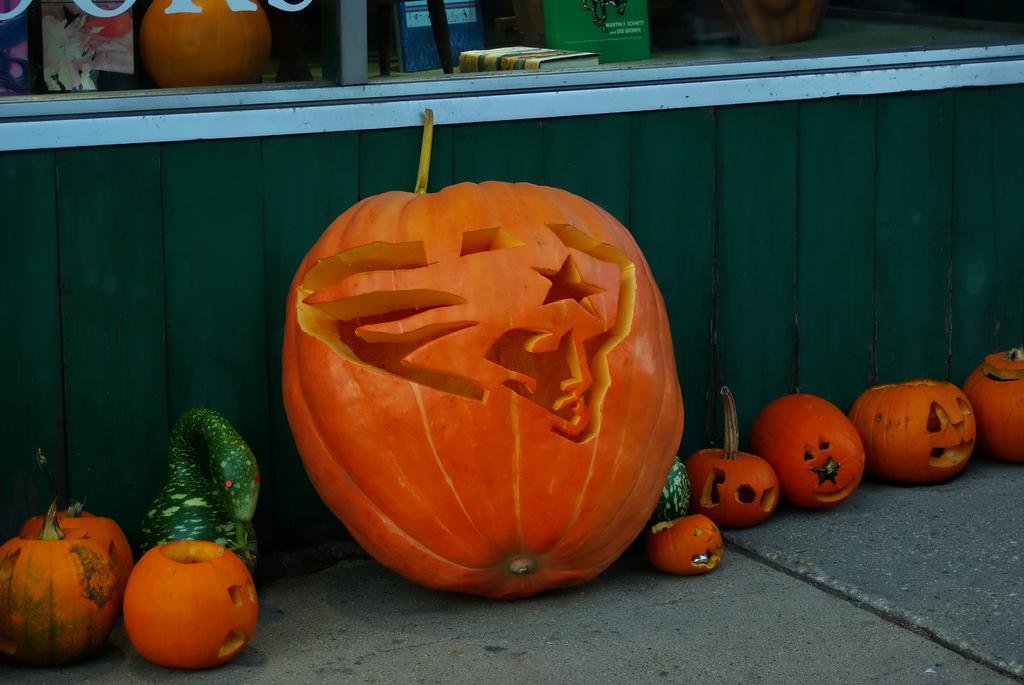Please provide a concise description of this image. In this image I can see few orange color pumpkins on the floor. Back I can see few objects. 